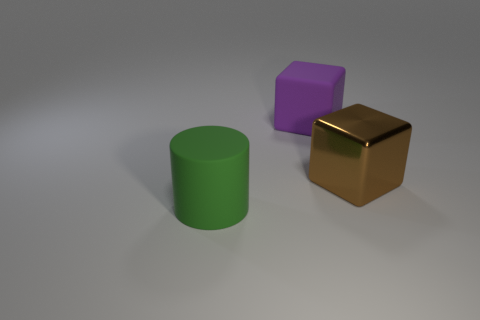Add 3 small yellow shiny cylinders. How many objects exist? 6 Subtract all cylinders. How many objects are left? 2 Add 1 purple matte objects. How many purple matte objects are left? 2 Add 2 cyan metal things. How many cyan metal things exist? 2 Subtract 0 brown spheres. How many objects are left? 3 Subtract all big cylinders. Subtract all cylinders. How many objects are left? 1 